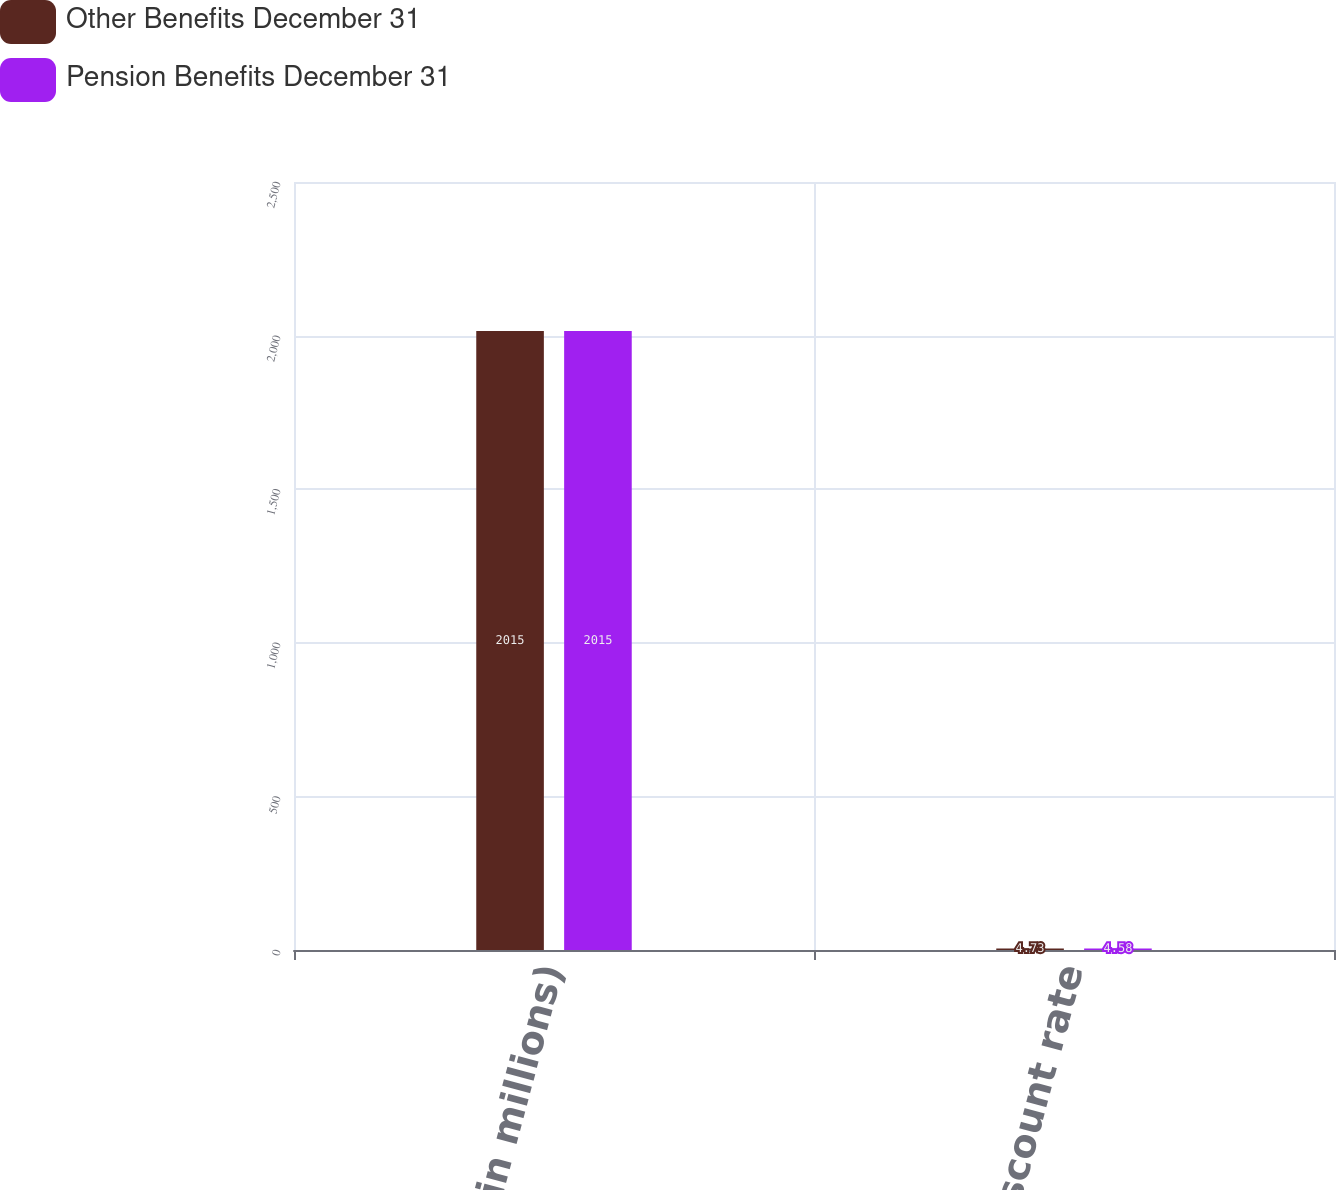<chart> <loc_0><loc_0><loc_500><loc_500><stacked_bar_chart><ecel><fcel>( in millions)<fcel>Discount rate<nl><fcel>Other Benefits December 31<fcel>2015<fcel>4.73<nl><fcel>Pension Benefits December 31<fcel>2015<fcel>4.58<nl></chart> 